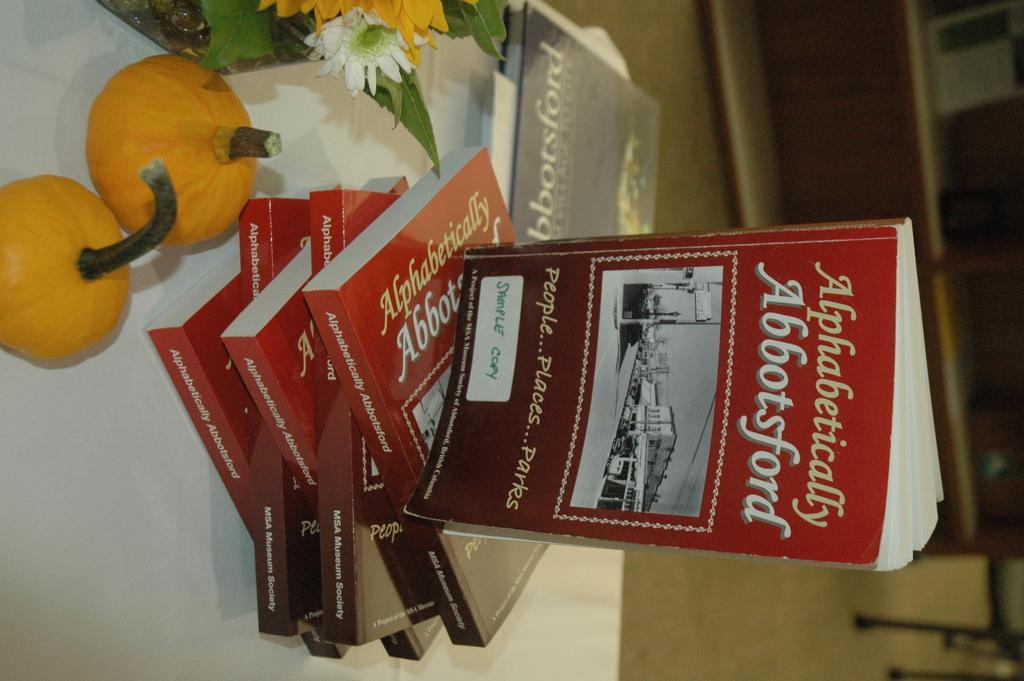What is the main piece of furniture in the image? There is a table in the image. What items can be seen on the table? There are books, flowers, and two fruits on the table. What is located on the right side of the image? There is a showcase on the right side of the image. What type of ornament is the cat wearing in the image? There is no cat present in the image, and therefore no ornament can be observed. 